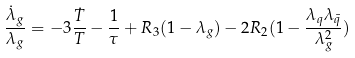<formula> <loc_0><loc_0><loc_500><loc_500>\frac { \dot { \lambda } _ { g } } { \lambda _ { g } } = - 3 \frac { \dot { T } } { T } - \frac { 1 } { \tau } + R _ { 3 } ( 1 - \lambda _ { g } ) - 2 R _ { 2 } ( 1 - \frac { \lambda _ { q } \lambda _ { \bar { q } } } { \lambda _ { g } ^ { 2 } } )</formula> 